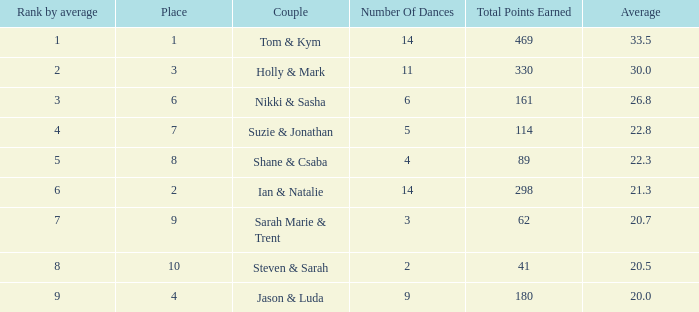What is the total points earned total number if the average is 21.3? 1.0. 